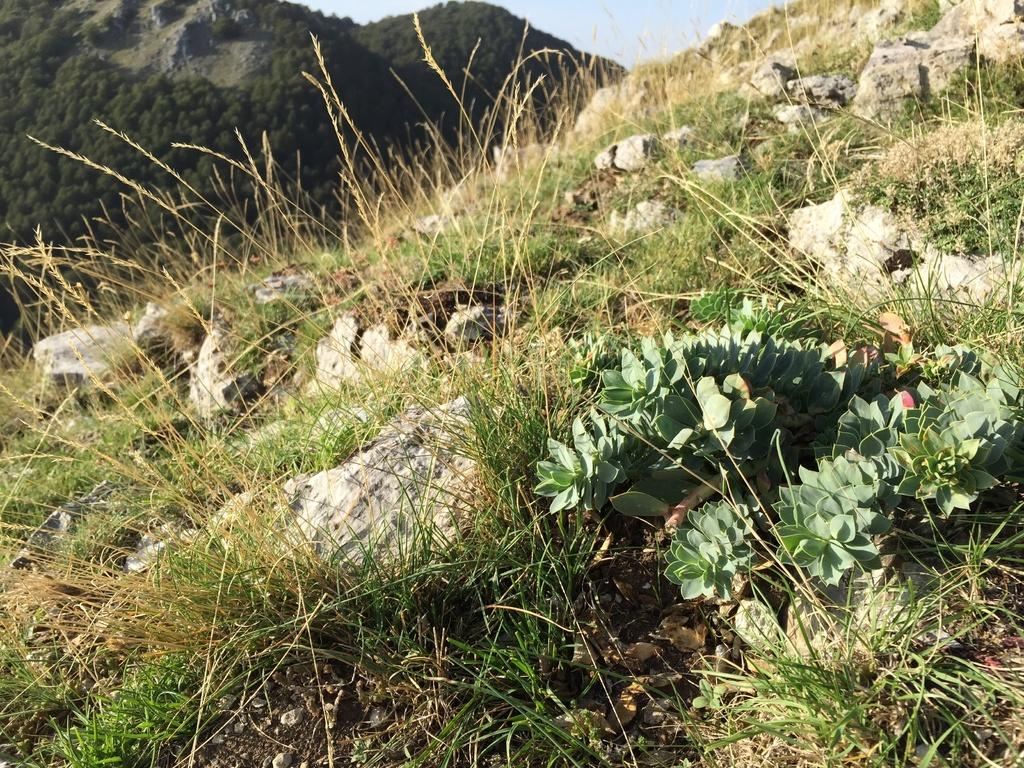What type of natural formation can be seen in the image? There are mountains in the image. What covers the mountains in the image? The mountains are covered with trees. What other features can be seen on the mountains? Stones, grass, and plants are present on the mountains. What is visible in the background of the image? The sky is visible in the image. What type of education can be seen being provided to the horse in the image? There is no horse present in the image, and therefore no education can be observed. 